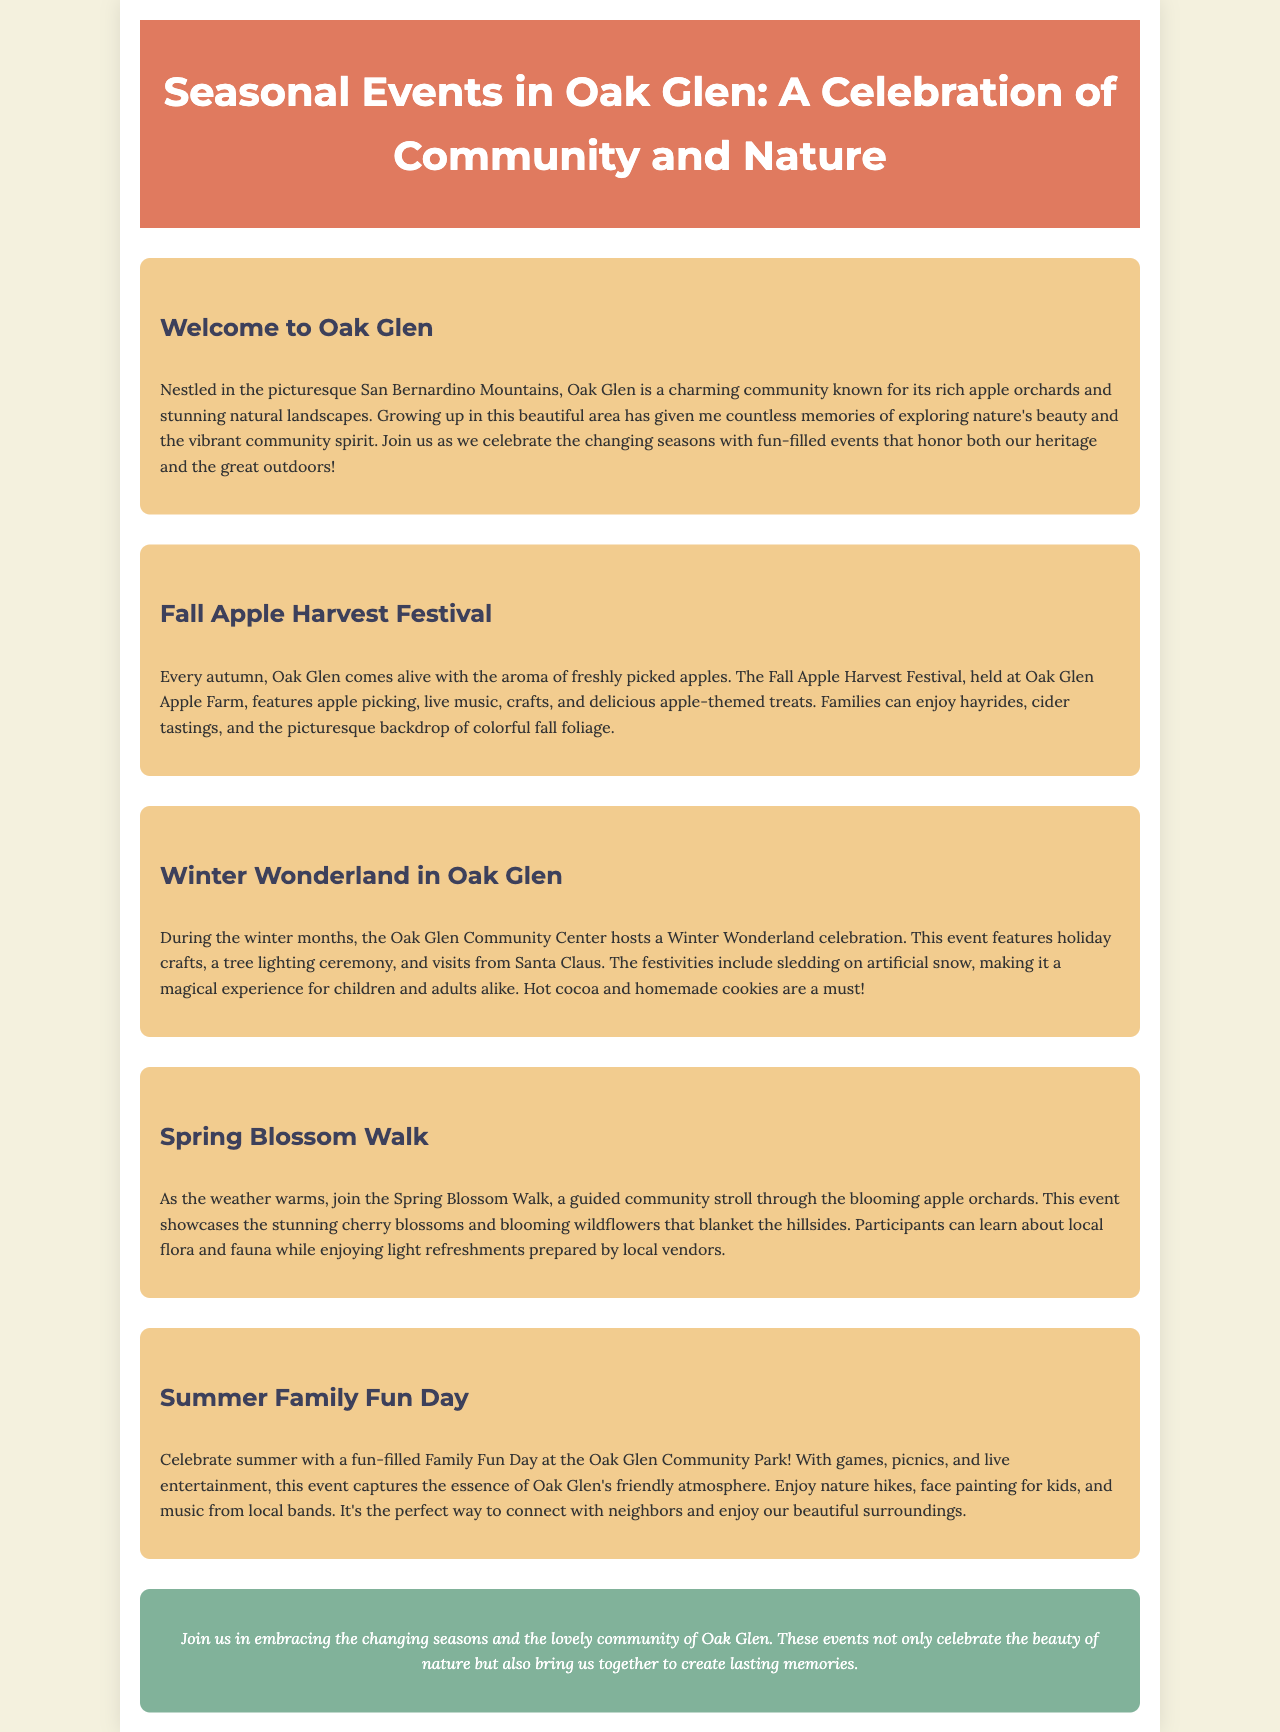what is the name of the festival held in autumn? The festival held in autumn is specifically mentioned as the Fall Apple Harvest Festival.
Answer: Fall Apple Harvest Festival what kind of crafts are available at the Winter Wonderland event? The Winter Wonderland event features holiday crafts as part of its activities.
Answer: holiday crafts which season does the Spring Blossom Walk take place? The Spring Blossom Walk occurs as the weather warms up, indicating that it takes place in spring.
Answer: spring what is highlighted during the Fall Apple Harvest Festival? The Fall Apple Harvest Festival highlights apple picking among other activities.
Answer: apple picking what treats are served at the Winter Wonderland celebration? The document mentions that hot cocoa and homemade cookies are served at the Winter Wonderland celebration.
Answer: hot cocoa and homemade cookies what type of entertainment is available during Summer Family Fun Day? Summer Family Fun Day includes live entertainment as part of its offerings.
Answer: live entertainment how does the brochure describe Oak Glen? The brochure describes Oak Glen as a charming community known for its rich apple orchards and stunning natural landscapes.
Answer: charming community known for its rich apple orchards and stunning natural landscapes who can children meet during Winter Wonderland? Children have the opportunity to meet Santa Claus during the Winter Wonderland celebration.
Answer: Santa Claus 